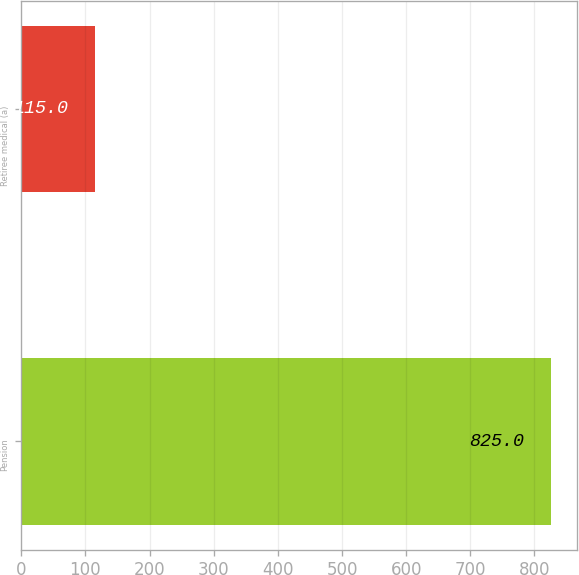Convert chart. <chart><loc_0><loc_0><loc_500><loc_500><bar_chart><fcel>Pension<fcel>Retiree medical (a)<nl><fcel>825<fcel>115<nl></chart> 